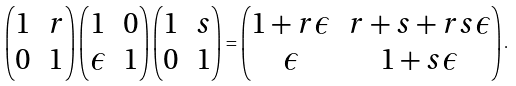Convert formula to latex. <formula><loc_0><loc_0><loc_500><loc_500>\begin{pmatrix} 1 & r \\ 0 & 1 \end{pmatrix} \begin{pmatrix} 1 & 0 \\ \epsilon & 1 \end{pmatrix} \begin{pmatrix} 1 & s \\ 0 & 1 \end{pmatrix} = \begin{pmatrix} 1 + r \epsilon & r + s + r s \epsilon \\ \epsilon & 1 + s \epsilon \end{pmatrix} .</formula> 